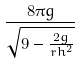Convert formula to latex. <formula><loc_0><loc_0><loc_500><loc_500>\frac { 8 \pi g } { \sqrt { 9 - \frac { 2 g } { r h ^ { 2 } } } }</formula> 